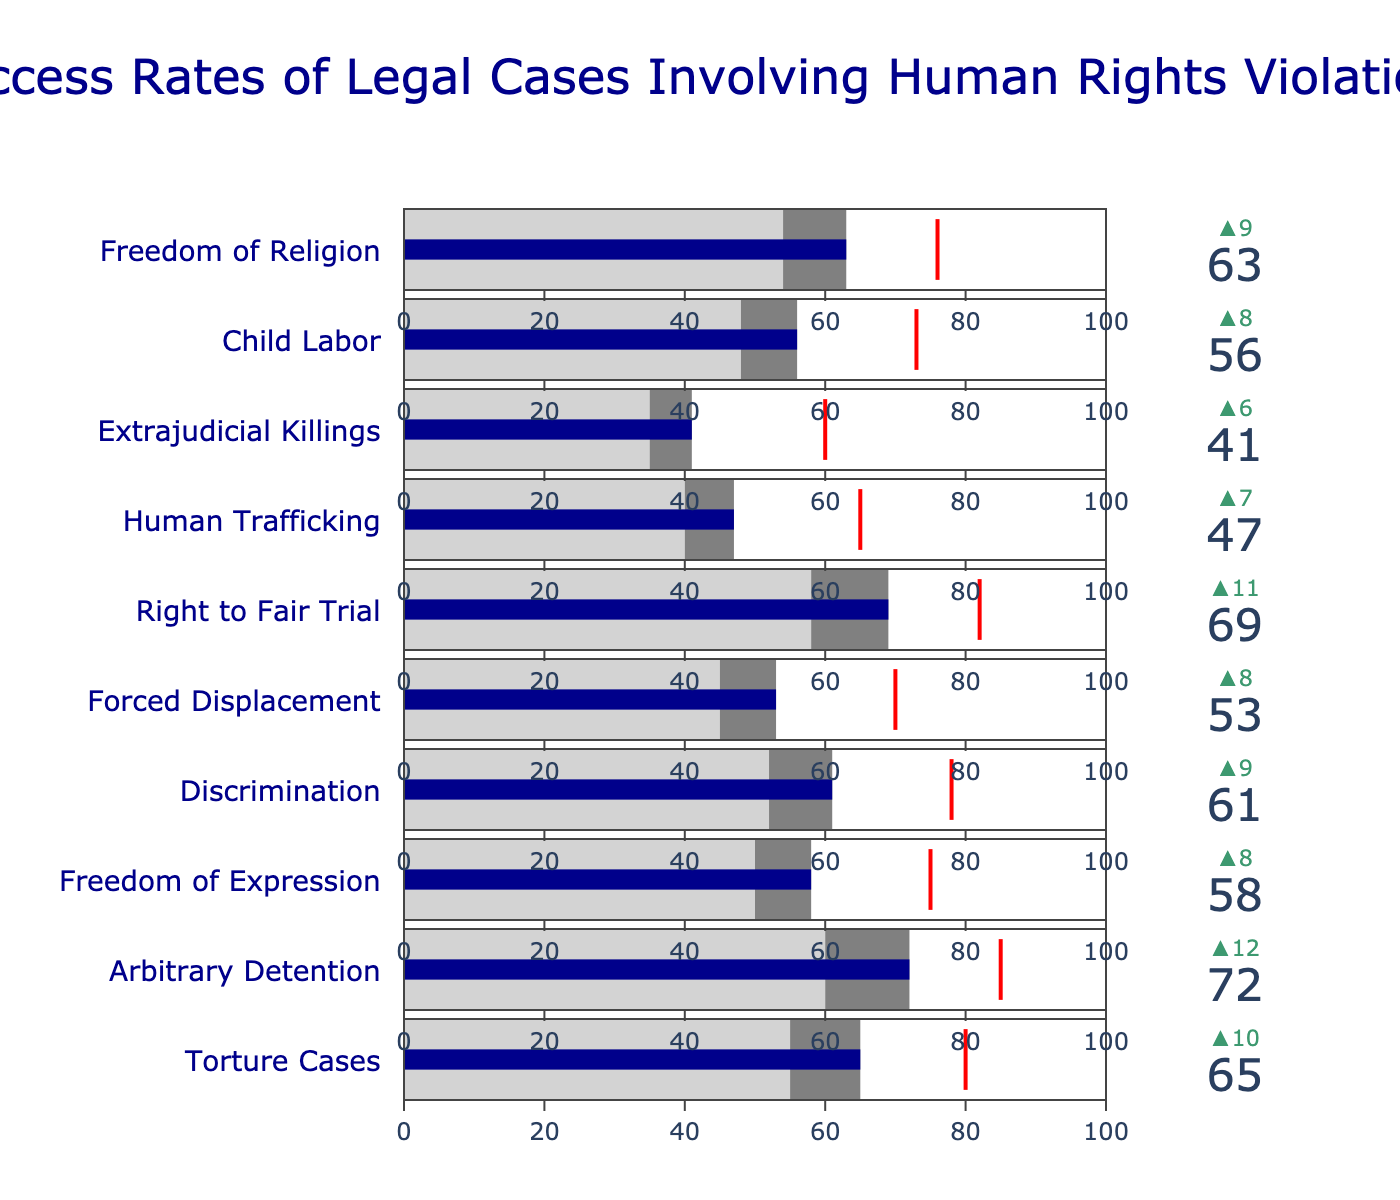What's the title of the figure? The title is located at the top of the figure and describes the content of the chart.
Answer: Success Rates of Legal Cases Involving Human Rights Violations What is the actual success rate for Torture Cases? Look at the value bar corresponding to "Torture Cases" in the chart; it indicates the actual success rate.
Answer: 65 Which category reports the lowest success rate? Compare all categories' actual success rates shown by the dark blue bars. The lowest number indicates the lowest success rate.
Answer: Extrajudicial Killings How does the success rate of Freedom of Religion compare with its target? Find the difference between the actual success rate and the target value for "Freedom of Religion".
Answer: It is 13 below the target Which categories have a higher actual success rate than comparative success rate? Identify all categories where the "Actual" value is greater than the "Comparative" value indicated by larger blue bars compared to gray sections.
Answer: Torture Cases, Arbitrary Detention, Freedom of Expression, Discrimination, Forced Displacement, Right to Fair Trial, Child Labor, Freedom of Religion How much higher is the success rate for the Right to Fair Trial compared to Freedom of Expression? Subtract the success rate of Freedom of Expression from the success rate of Right to Fair Trial.
Answer: 69 - 58 = 11 In which category is the success rate closest to its target? For each category, calculate the absolute difference between actual success rates and targets. The smallest difference indicates the closest success rate to its target
Answer: Freedom of Religion (63 vs. 76, a 13-point difference) What is the average actual success rate across all categories? Add up all the actual success rates and divide by the number of categories. (65+72+58+61+53+69+47+41+56+63)/10 = 58.5
Answer: 58.5 Which category has a delta value of 20? Look at the top of the indicator panel for each category to identify which one has a delta value of 20.
Answer: Arbitrary Detention How much lower is the actual success rate for Human Trafficking than its target? Subtract the actual success rate of Human Trafficking from its target value.
Answer: 65 - 47 = 18 